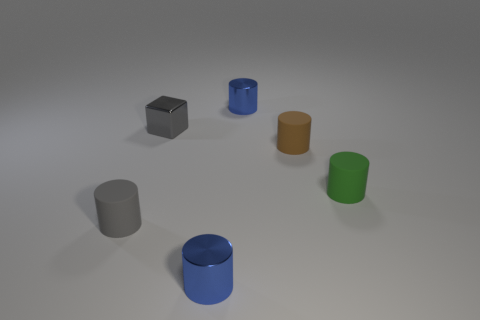Subtract all gray cylinders. How many cylinders are left? 4 Subtract all tiny green cylinders. How many cylinders are left? 4 Subtract all cyan cylinders. Subtract all green spheres. How many cylinders are left? 5 Add 1 small rubber things. How many objects exist? 7 Subtract all blocks. How many objects are left? 5 Add 2 small gray matte things. How many small gray matte things exist? 3 Subtract 1 brown cylinders. How many objects are left? 5 Subtract all matte cylinders. Subtract all green cylinders. How many objects are left? 2 Add 1 small rubber cylinders. How many small rubber cylinders are left? 4 